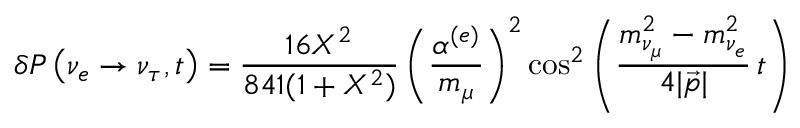Convert formula to latex. <formula><loc_0><loc_0><loc_500><loc_500>\delta P \left ( \nu _ { e } \rightarrow \nu _ { \tau } , t \right ) = \frac { 1 6 X ^ { 2 } } { 8 4 1 ( 1 + X ^ { 2 } ) } \left ( \frac { \alpha ^ { ( e ) } } { m _ { \mu } } \right ) ^ { 2 } \cos ^ { 2 } \left ( \frac { m _ { \nu _ { \mu } } ^ { 2 } - m _ { \nu _ { e } } ^ { 2 } } { 4 | \vec { p } | } \, t \right )</formula> 